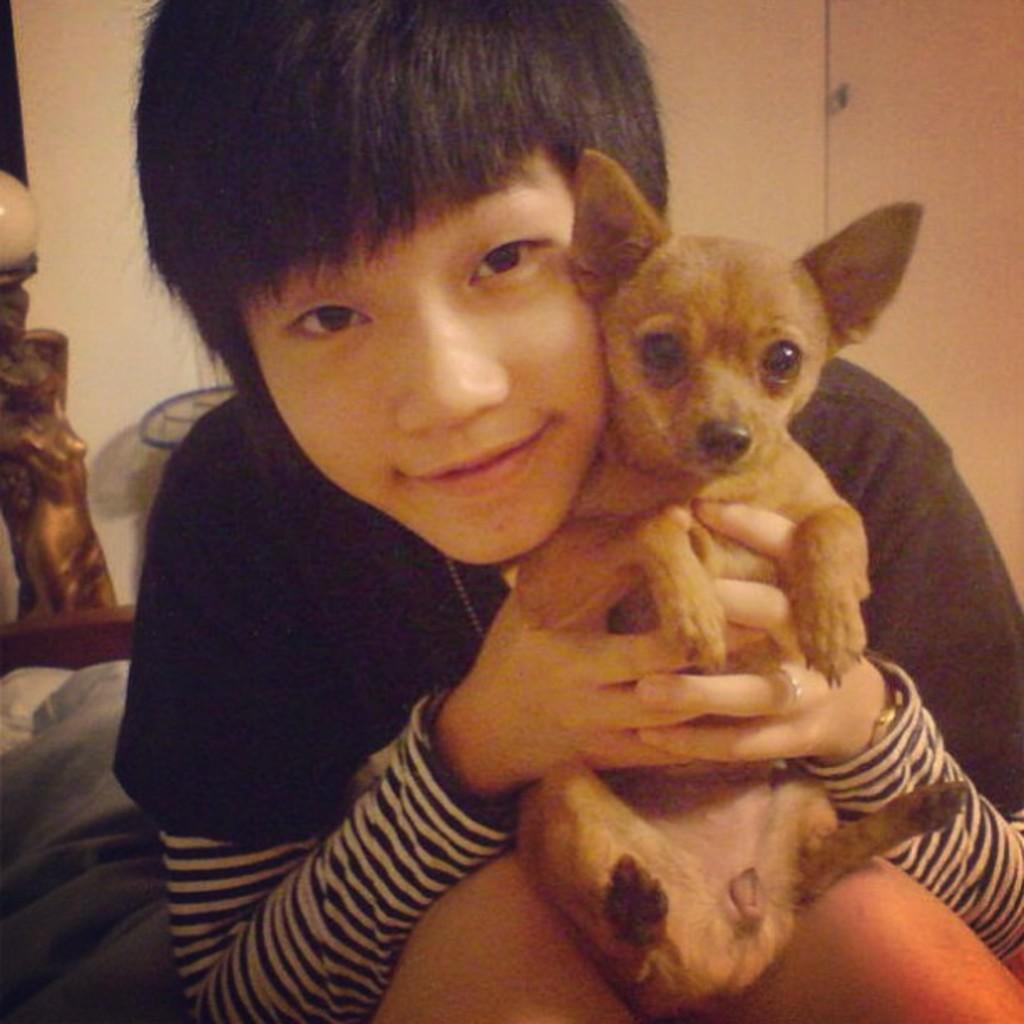How would you summarize this image in a sentence or two? In this picture there is a boy holding a puppy in both hands 